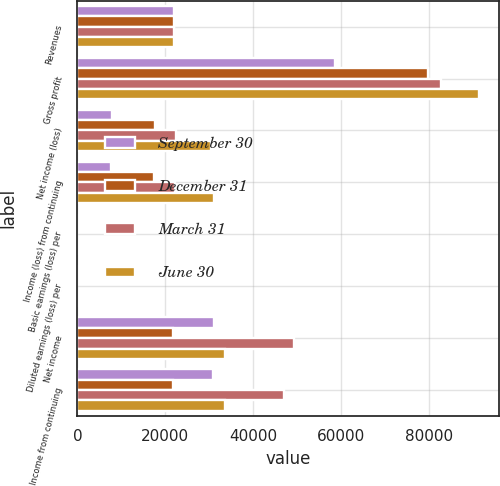Convert chart to OTSL. <chart><loc_0><loc_0><loc_500><loc_500><stacked_bar_chart><ecel><fcel>Revenues<fcel>Gross profit<fcel>Net income (loss)<fcel>Income (loss) from continuing<fcel>Basic earnings (loss) per<fcel>Diluted earnings (loss) per<fcel>Net income<fcel>Income from continuing<nl><fcel>September 30<fcel>22082<fcel>58780<fcel>7859<fcel>7614<fcel>0.07<fcel>0.07<fcel>31204<fcel>30867<nl><fcel>December 31<fcel>22082<fcel>79829<fcel>17659<fcel>17481<fcel>0.15<fcel>0.14<fcel>21865<fcel>21783<nl><fcel>March 31<fcel>22082<fcel>82742<fcel>22423<fcel>22299<fcel>0.19<fcel>0.17<fcel>49321<fcel>46950<nl><fcel>June 30<fcel>22082<fcel>91365<fcel>30458<fcel>31161<fcel>0.27<fcel>0.27<fcel>33587<fcel>33540<nl></chart> 